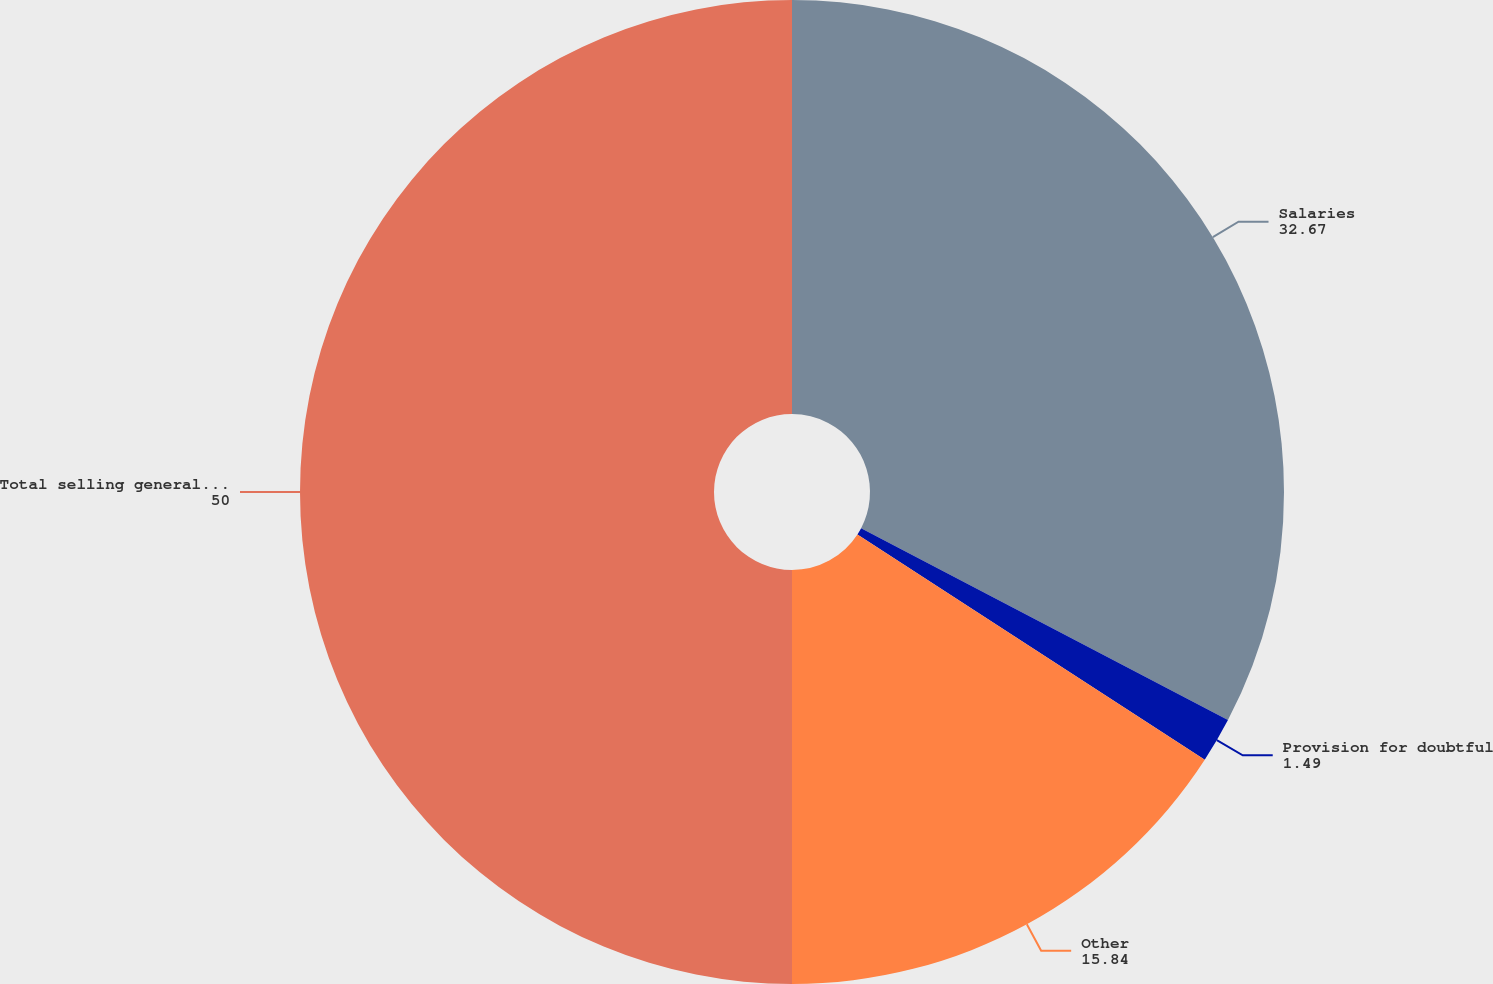Convert chart. <chart><loc_0><loc_0><loc_500><loc_500><pie_chart><fcel>Salaries<fcel>Provision for doubtful<fcel>Other<fcel>Total selling general and<nl><fcel>32.67%<fcel>1.49%<fcel>15.84%<fcel>50.0%<nl></chart> 